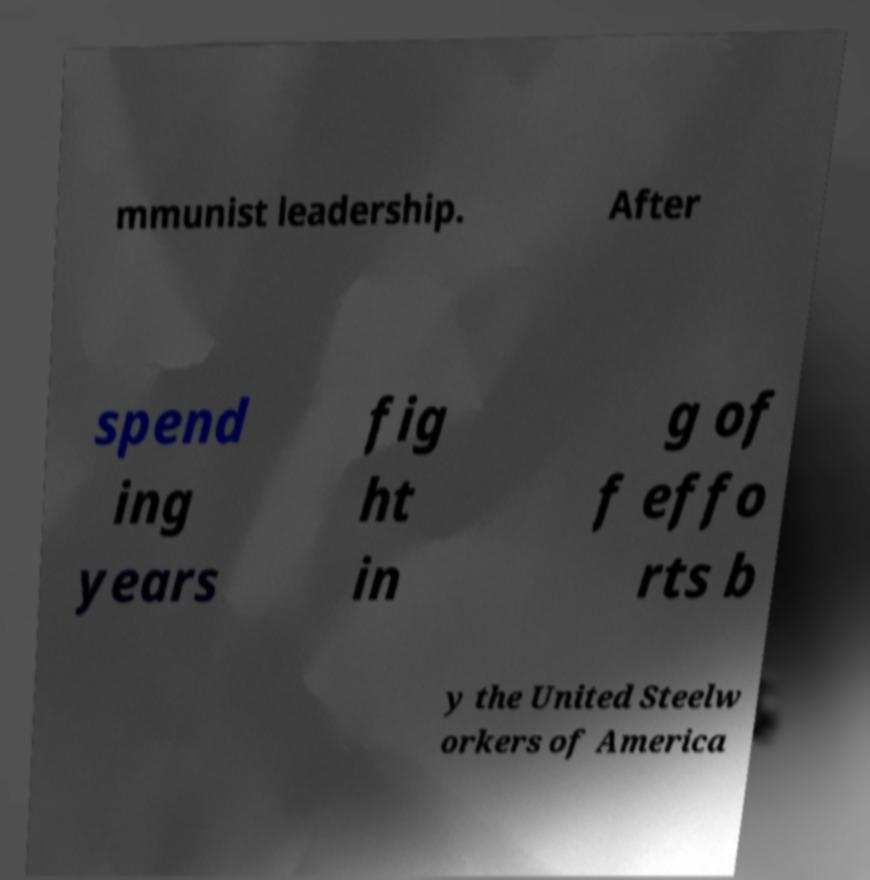Please identify and transcribe the text found in this image. mmunist leadership. After spend ing years fig ht in g of f effo rts b y the United Steelw orkers of America 